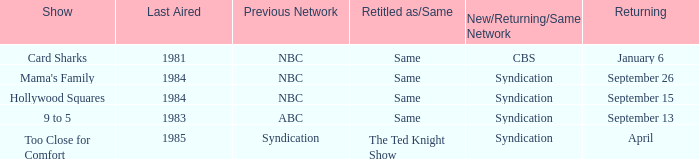What was the earliest aired show that's returning on September 13? 1983.0. 